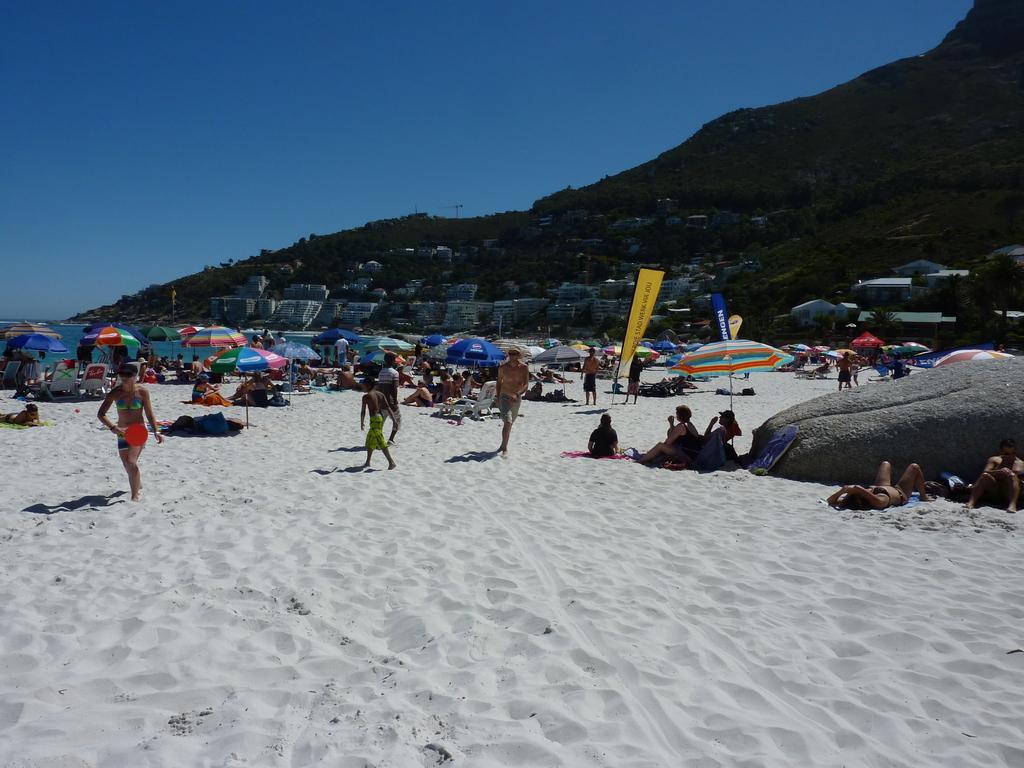How would you summarize this image in a sentence or two? In this image, there are a few people, trees, umbrellas, hills, houses, resting chairs. We can see the ground with some objects. We can also see a rock on the right. We can also see the sky. 